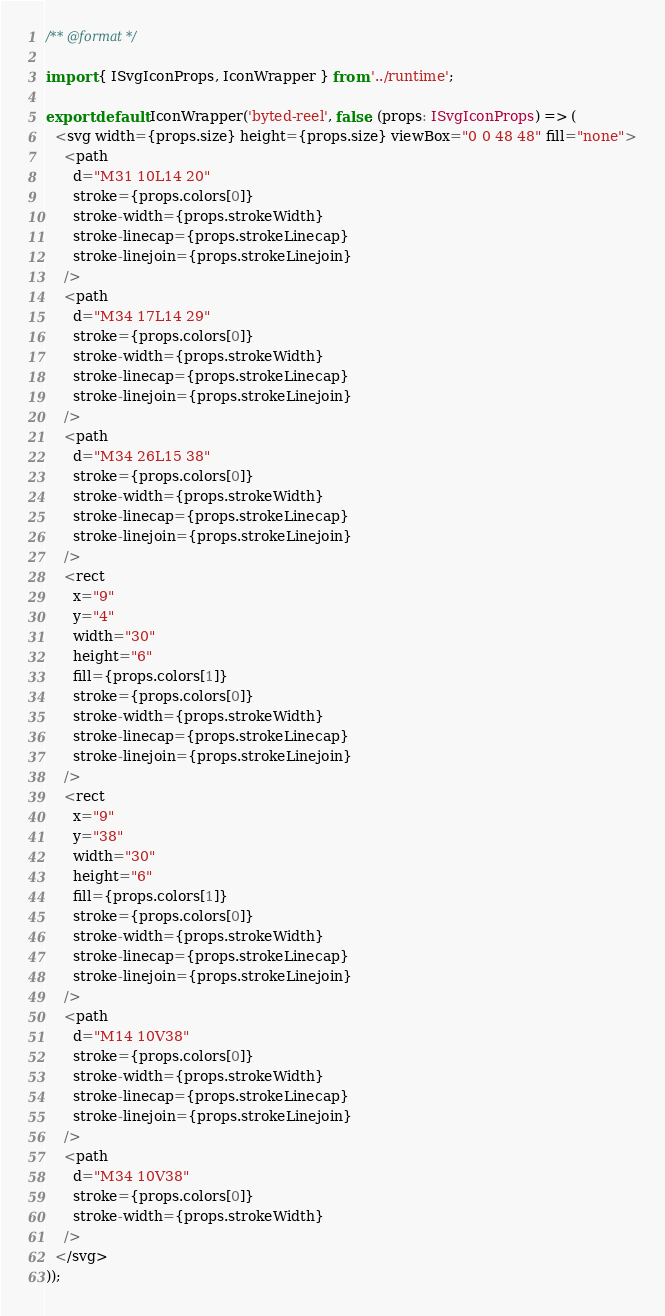<code> <loc_0><loc_0><loc_500><loc_500><_TypeScript_>/** @format */

import { ISvgIconProps, IconWrapper } from '../runtime';

export default IconWrapper('byted-reel', false, (props: ISvgIconProps) => (
  <svg width={props.size} height={props.size} viewBox="0 0 48 48" fill="none">
    <path
      d="M31 10L14 20"
      stroke={props.colors[0]}
      stroke-width={props.strokeWidth}
      stroke-linecap={props.strokeLinecap}
      stroke-linejoin={props.strokeLinejoin}
    />
    <path
      d="M34 17L14 29"
      stroke={props.colors[0]}
      stroke-width={props.strokeWidth}
      stroke-linecap={props.strokeLinecap}
      stroke-linejoin={props.strokeLinejoin}
    />
    <path
      d="M34 26L15 38"
      stroke={props.colors[0]}
      stroke-width={props.strokeWidth}
      stroke-linecap={props.strokeLinecap}
      stroke-linejoin={props.strokeLinejoin}
    />
    <rect
      x="9"
      y="4"
      width="30"
      height="6"
      fill={props.colors[1]}
      stroke={props.colors[0]}
      stroke-width={props.strokeWidth}
      stroke-linecap={props.strokeLinecap}
      stroke-linejoin={props.strokeLinejoin}
    />
    <rect
      x="9"
      y="38"
      width="30"
      height="6"
      fill={props.colors[1]}
      stroke={props.colors[0]}
      stroke-width={props.strokeWidth}
      stroke-linecap={props.strokeLinecap}
      stroke-linejoin={props.strokeLinejoin}
    />
    <path
      d="M14 10V38"
      stroke={props.colors[0]}
      stroke-width={props.strokeWidth}
      stroke-linecap={props.strokeLinecap}
      stroke-linejoin={props.strokeLinejoin}
    />
    <path
      d="M34 10V38"
      stroke={props.colors[0]}
      stroke-width={props.strokeWidth}
    />
  </svg>
));
</code> 